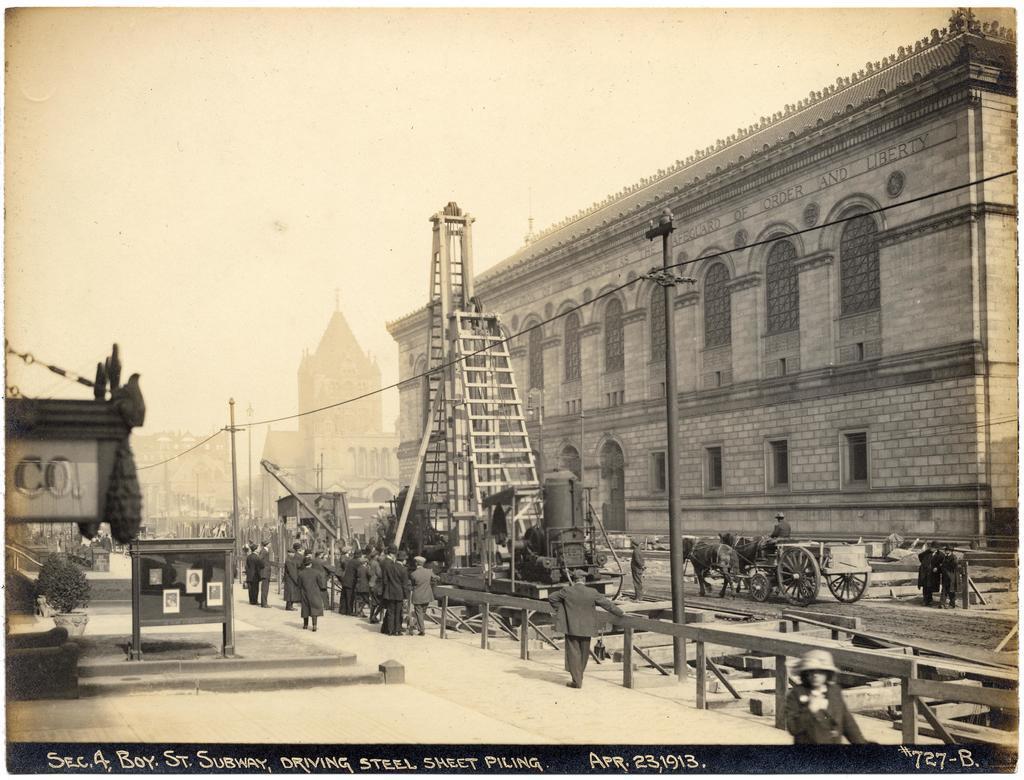Can you describe this image briefly? In this image, we can see a photocopy. In the photocopy, there are a few people, buildings and poles with wires. We can see the ground with some objects. We can also see a few carts with animals. We can see some text at the bottom. 